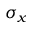Convert formula to latex. <formula><loc_0><loc_0><loc_500><loc_500>\sigma _ { x }</formula> 